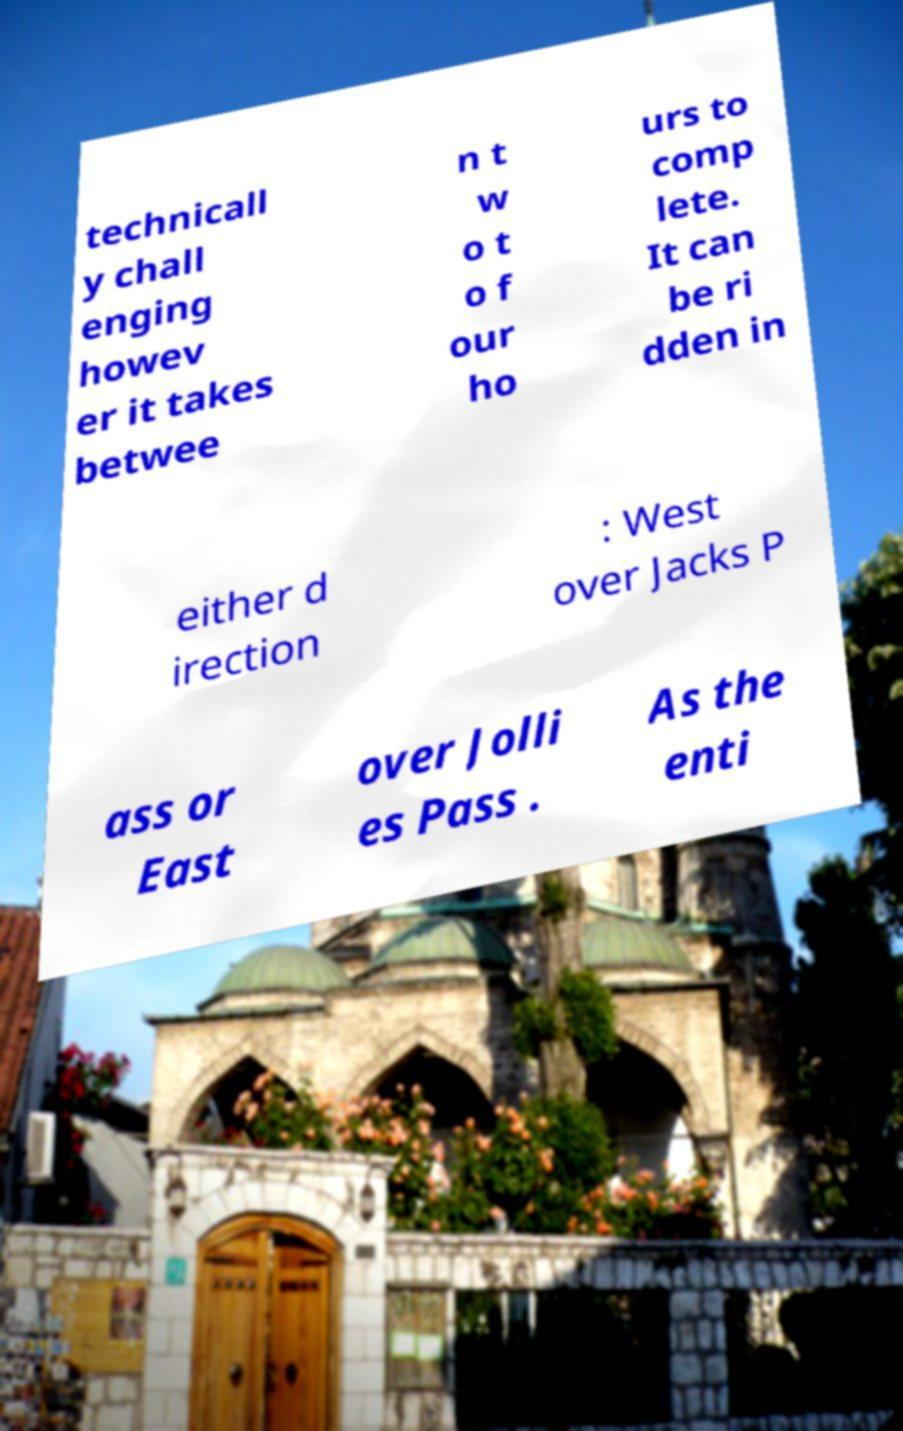Could you extract and type out the text from this image? technicall y chall enging howev er it takes betwee n t w o t o f our ho urs to comp lete. It can be ri dden in either d irection : West over Jacks P ass or East over Jolli es Pass . As the enti 